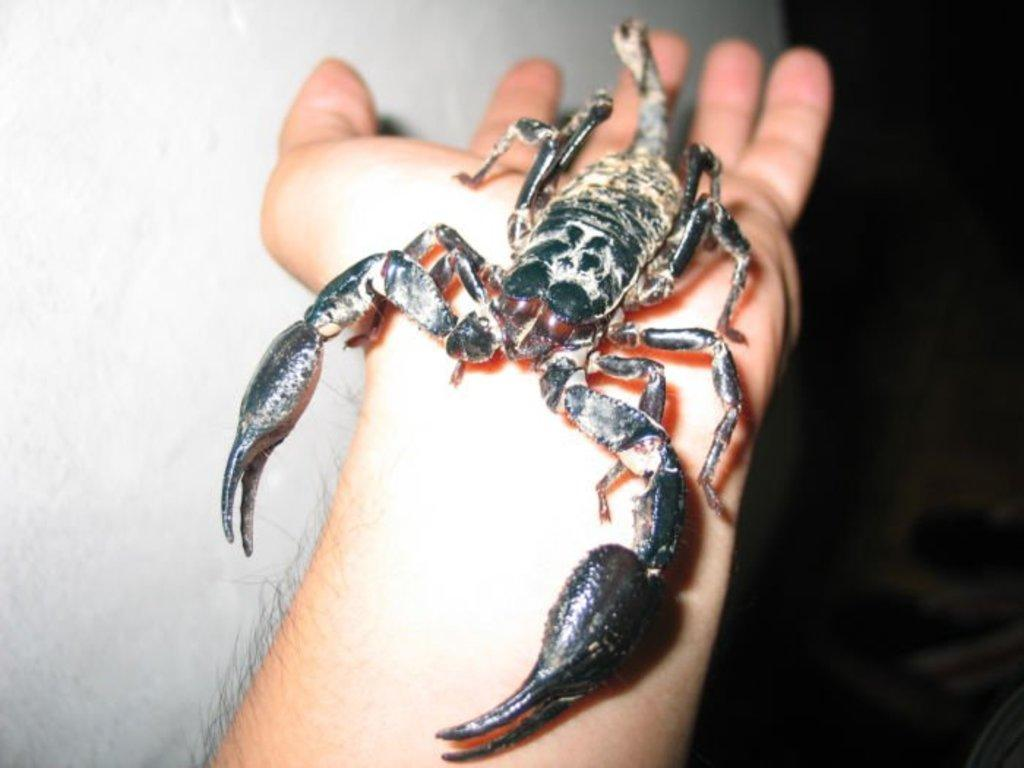What is the main subject of the picture? The main subject of the picture is a scorpion. Where is the scorpion located in the image? The scorpion is on a person's hand. How would you describe the lighting on the right side of the image? The right side of the image is dark. What can be seen in the background on the left side of the image? There is a white color wall in the background on the left side of the image. What type of store can be seen in the background of the image? There is no store visible in the background of the image; it only shows a scorpion on a person's hand, a dark right side, and a white wall in the background on the left side. 